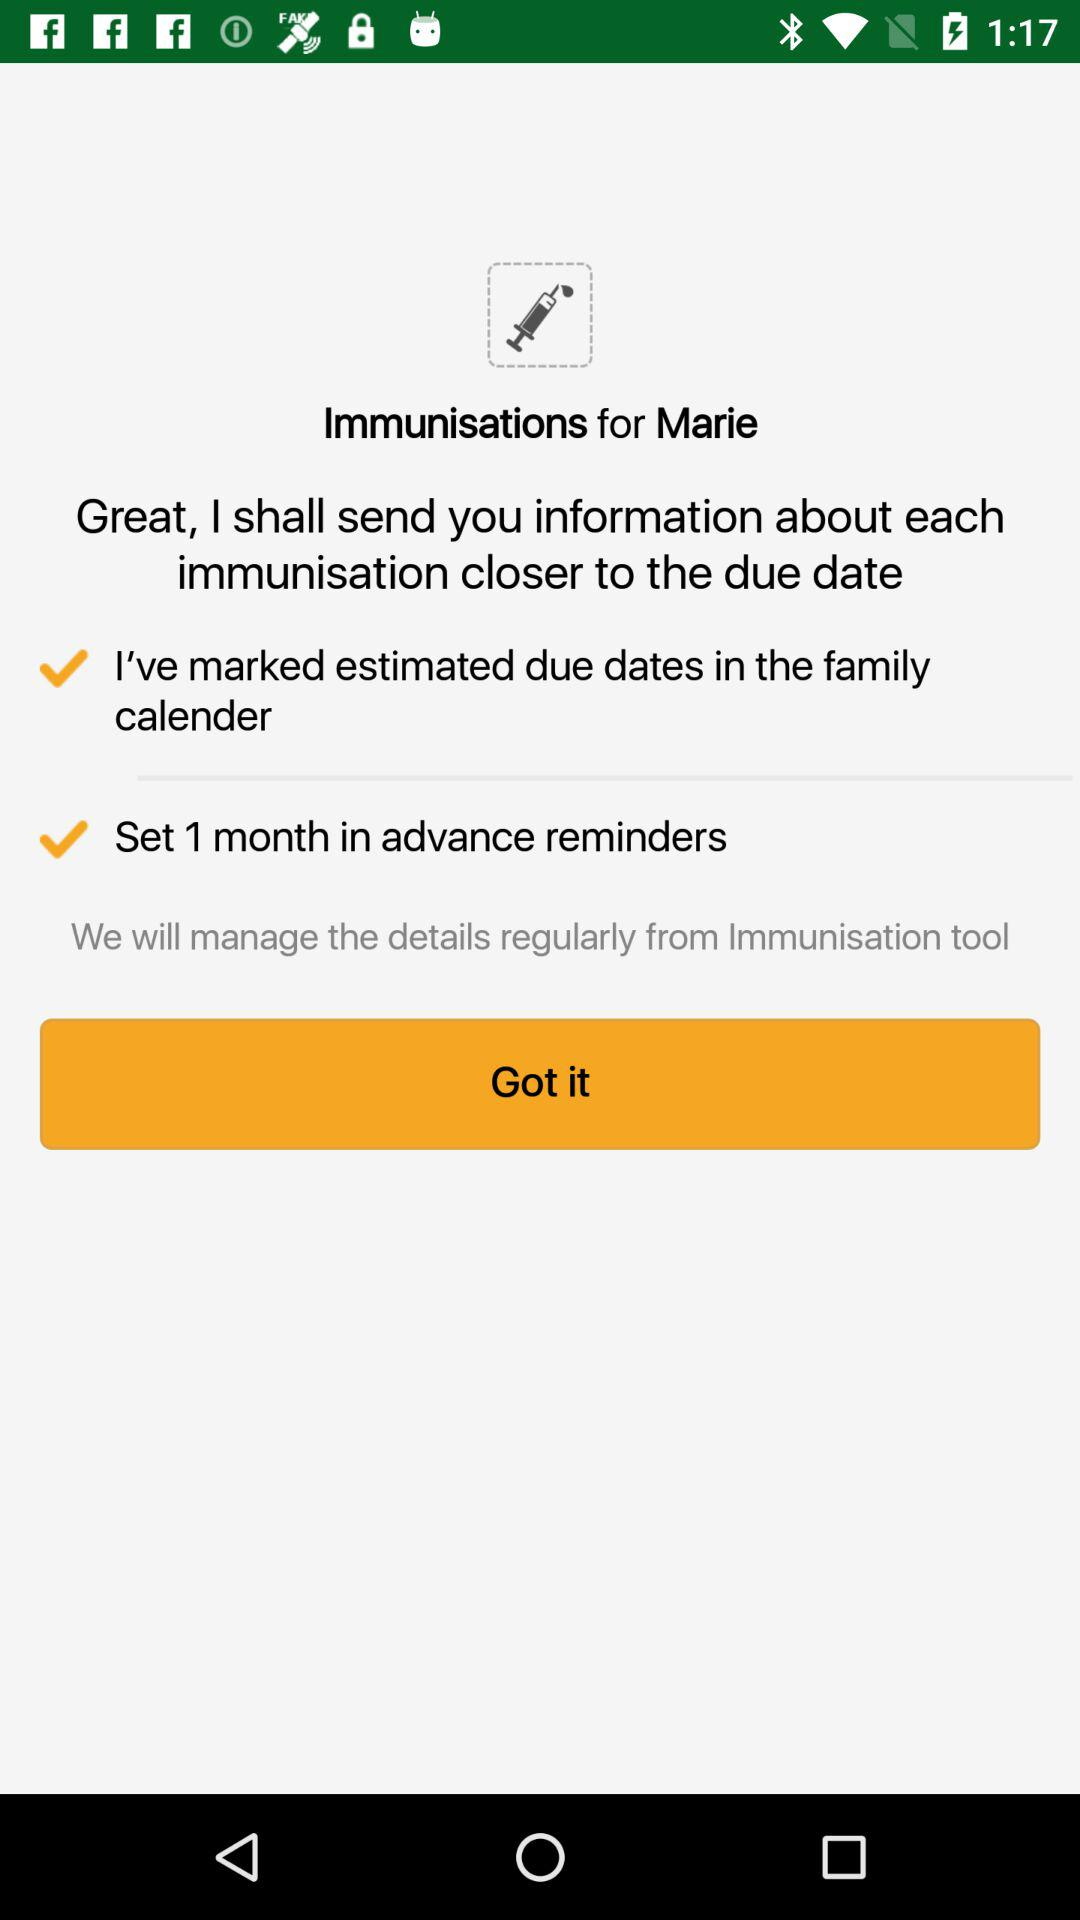For how many months are advance reminders set? Advance reminder is set for 1 month. 